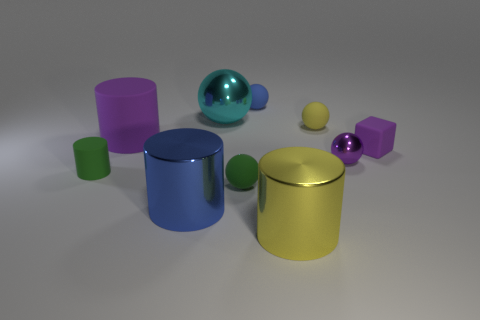Subtract all green rubber spheres. How many spheres are left? 4 Subtract all cyan spheres. How many spheres are left? 4 Subtract all red balls. Subtract all cyan blocks. How many balls are left? 5 Subtract 0 cyan cylinders. How many objects are left? 10 Subtract all cylinders. How many objects are left? 6 Subtract all big yellow shiny objects. Subtract all blue metal things. How many objects are left? 8 Add 5 purple metallic things. How many purple metallic things are left? 6 Add 7 gray metallic cylinders. How many gray metallic cylinders exist? 7 